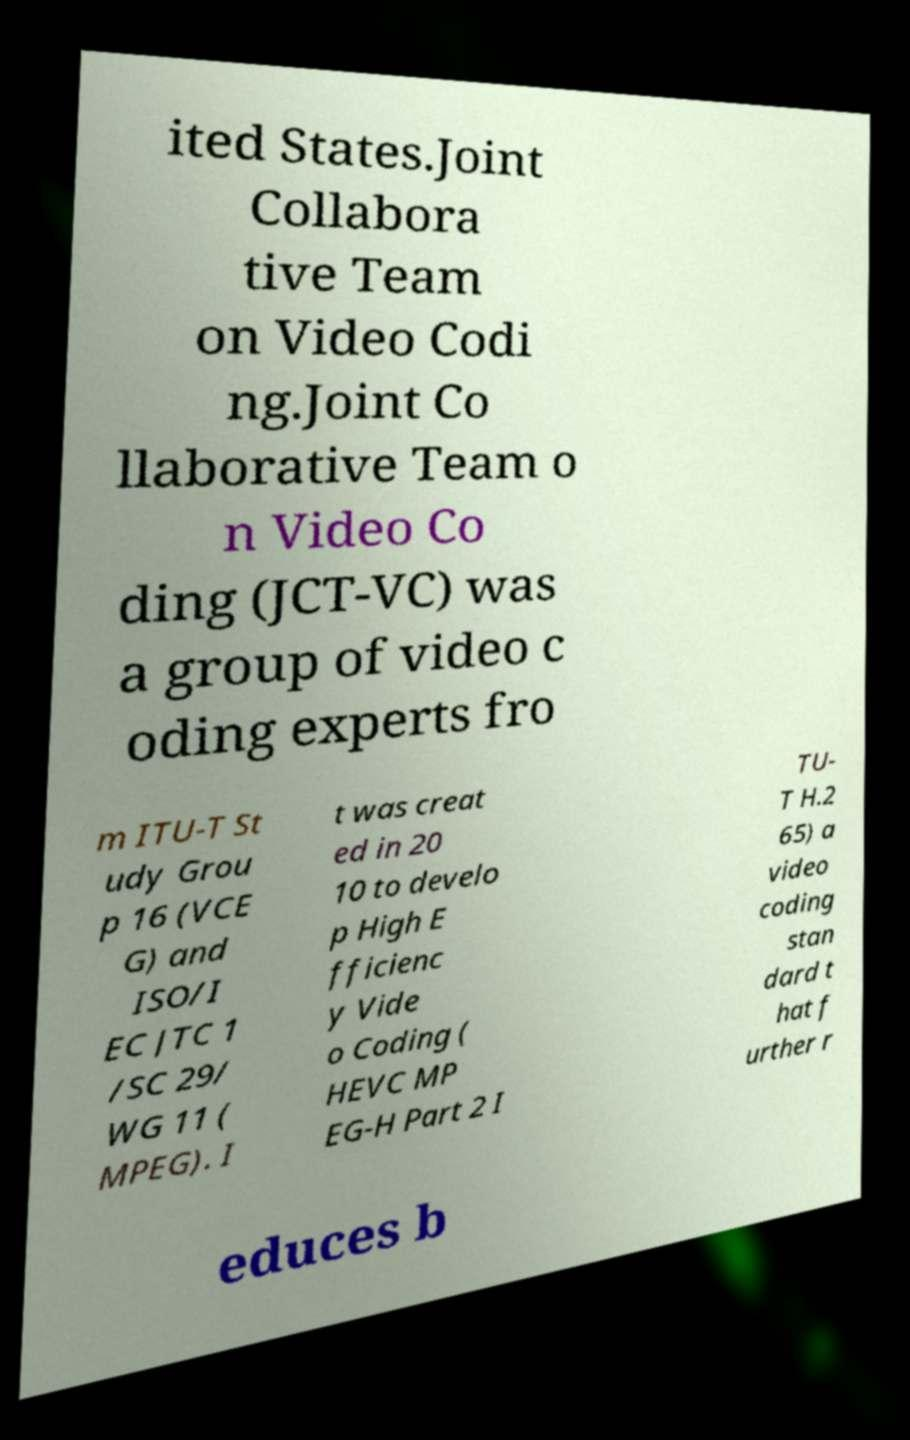Please read and relay the text visible in this image. What does it say? ited States.Joint Collabora tive Team on Video Codi ng.Joint Co llaborative Team o n Video Co ding (JCT-VC) was a group of video c oding experts fro m ITU-T St udy Grou p 16 (VCE G) and ISO/I EC JTC 1 /SC 29/ WG 11 ( MPEG). I t was creat ed in 20 10 to develo p High E fficienc y Vide o Coding ( HEVC MP EG-H Part 2 I TU- T H.2 65) a video coding stan dard t hat f urther r educes b 